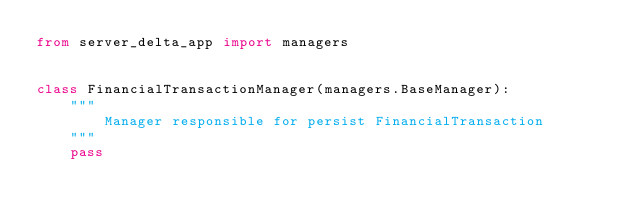Convert code to text. <code><loc_0><loc_0><loc_500><loc_500><_Python_>from server_delta_app import managers


class FinancialTransactionManager(managers.BaseManager):
    """
        Manager responsible for persist FinancialTransaction
    """
    pass
</code> 